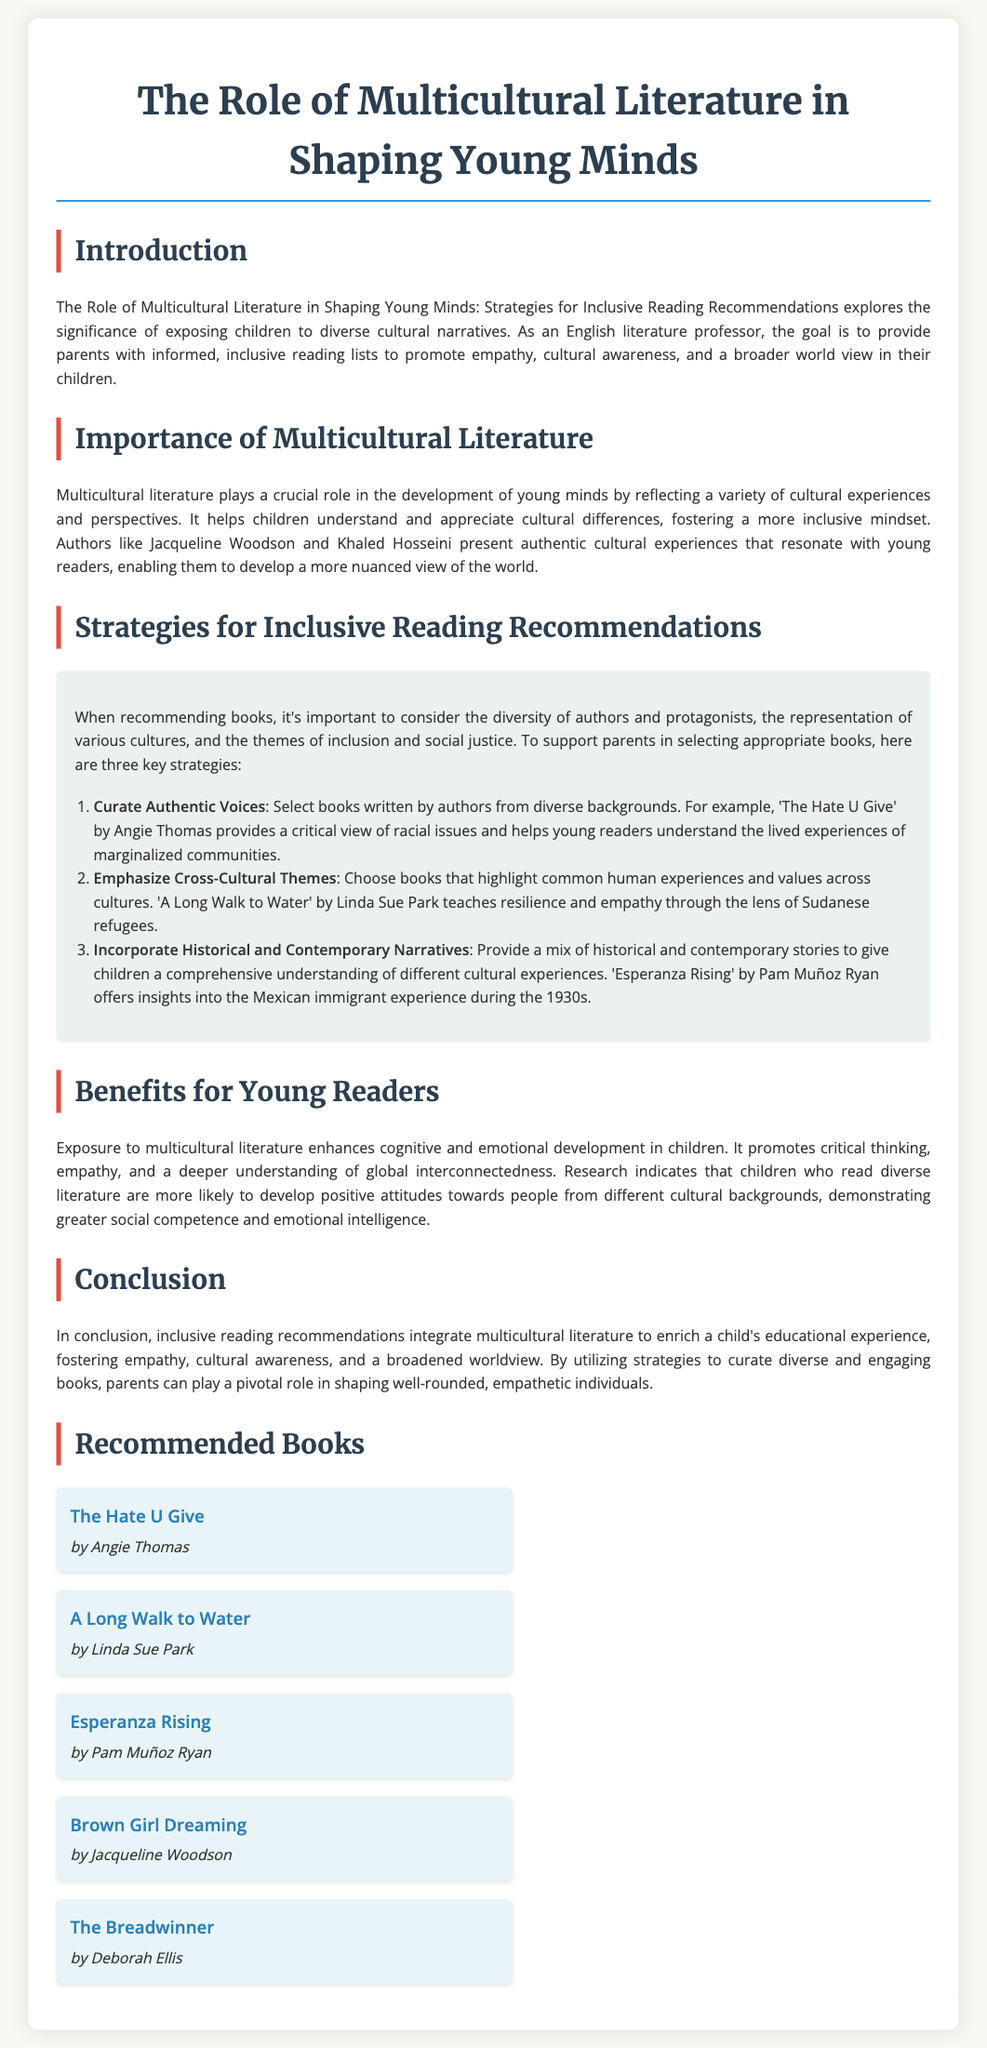What is the title of the whitepaper? The title is mentioned at the start of the document and highlights the focus on multicultural literature and young minds.
Answer: The Role of Multicultural Literature in Shaping Young Minds Who is the author of 'The Hate U Give'? The author is mentioned in the list of recommended books, which includes the names of the authors next to their titles.
Answer: Angie Thomas What is one of the benefits of multicultural literature for young readers? The document lists various benefits, with empathy being one of the prominent ones discussed.
Answer: Empathy What is the first strategy recommended for inclusive reading? The strategies provided in the document are listed in order, with the first being clearly highlighted.
Answer: Curate Authentic Voices How many recommended books are listed in the document? The total count can be easily found by counting the entries in the recommended books section.
Answer: Five Name one author mentioned in the document. The document lists several authors in the context of multicultural literature, making this information easy to retrieve.
Answer: Jacqueline Woodson What theme is highlighted in 'A Long Walk to Water'? The document summarizes the themes of books in the reading recommendations, specifically mentioning resilience.
Answer: Resilience Which author addresses racial issues in their work? Specific authors are linked to particular themes or issues in their books as discussed in the document.
Answer: Angie Thomas What type of literature does the whitepaper focus on? The introduction provides a clear indication of the type of literature being discussed throughout the document.
Answer: Multicultural literature 